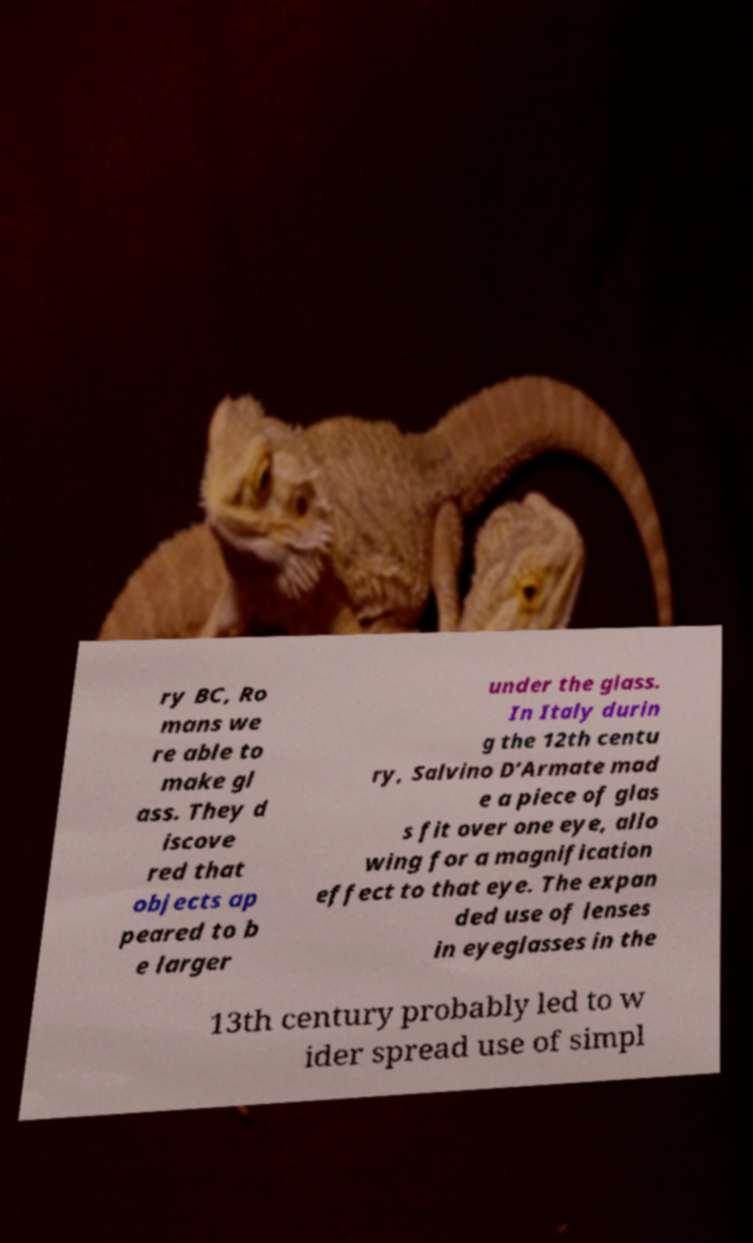Can you accurately transcribe the text from the provided image for me? ry BC, Ro mans we re able to make gl ass. They d iscove red that objects ap peared to b e larger under the glass. In Italy durin g the 12th centu ry, Salvino D’Armate mad e a piece of glas s fit over one eye, allo wing for a magnification effect to that eye. The expan ded use of lenses in eyeglasses in the 13th century probably led to w ider spread use of simpl 